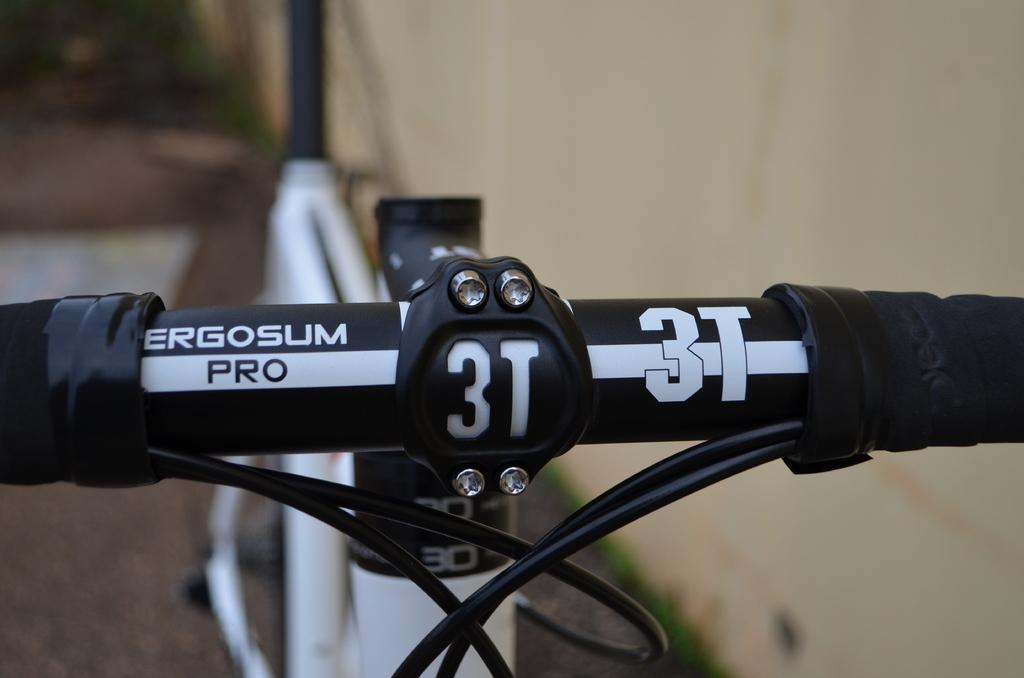What part of a bicycle can be seen in the image? There is a handle of a bicycle in the image. Can you describe another part of the bicycle visible in the image? There is a seatpost on the top left side of the image. How does the boy interact with the sand in the image? There is no boy or sand present in the image; it only features a handle and a seatpost of a bicycle. 